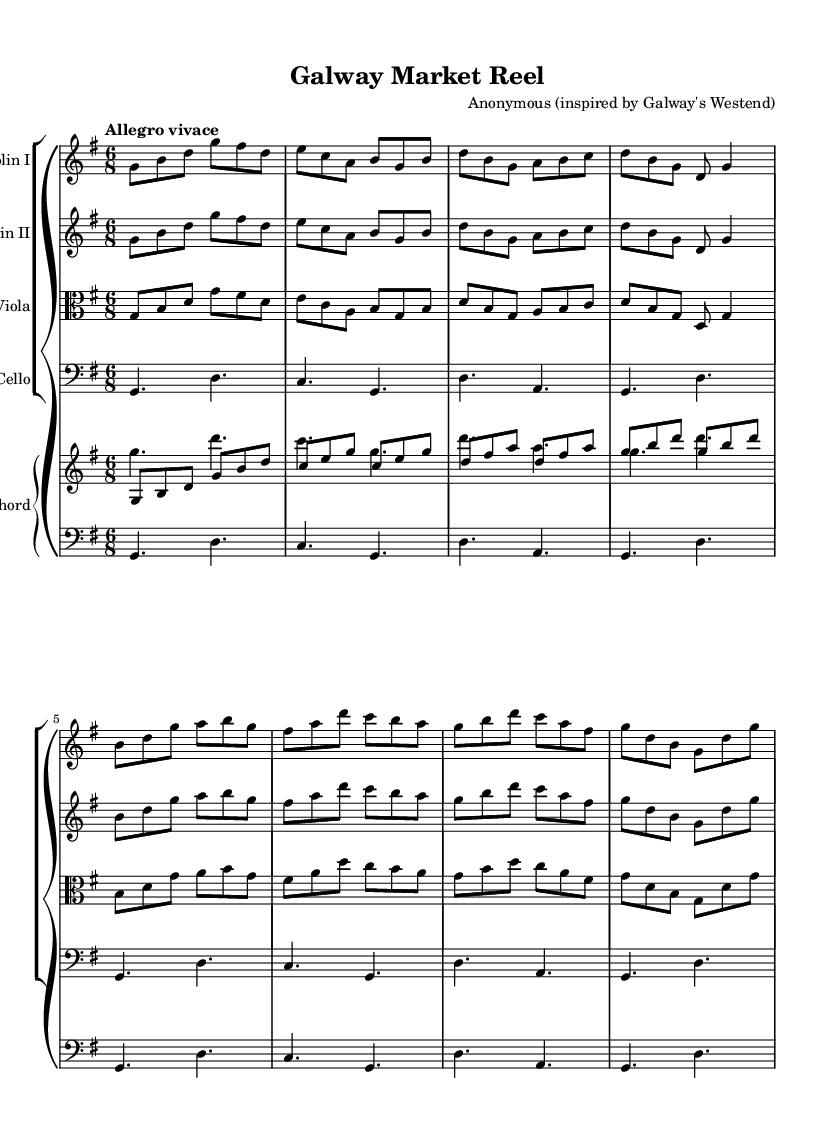What is the key signature of this piece? The key signature is indicated by the symbols at the beginning of the staff. In this case, there is one sharp (F#), which makes the key signature G major.
Answer: G major What is the time signature of this music? The time signature is found at the beginning of the score, represented as a fractional notation indicating how many beats are in each measure and what note value is a beat. Here, it shows 6/8, which means there are 6 eighth notes per measure.
Answer: 6/8 What is the tempo marking of the piece? The tempo marking is provided above the staff, indicating the speed of the piece. In this score, it says "Allegro vivace," which translates to a fast and lively pace.
Answer: Allegro vivace How many instruments are used in this score? The score comprises several independent staves, each labeled with an instrument name at the beginning. Counting those will tell us the total number of instruments. In this case, there are four instruments listed: two violins, a viola, and a cello.
Answer: Four Which section contains the cello part? The cello plays in the lowest voice of the GrandStaff, usually notated in the bass clef. In this score, the cello is part of the last staff of the GrandStaff.
Answer: Last What style of music does this piece belong to? The overall characteristics of the music, including the use of stylized dance rhythms and typical instrumentation for the era, identify it as Baroque. The lively dance suites evoke a festive atmosphere typical of Baroque compositions.
Answer: Baroque What is the nature of the piece described in the title? The title "Galway Market Reel" suggests that this music has a lively, dance-like character, often associated with folk traditions. The term "Reel" specifically refers to a type of dance that is fast and engaging.
Answer: Lively dance 